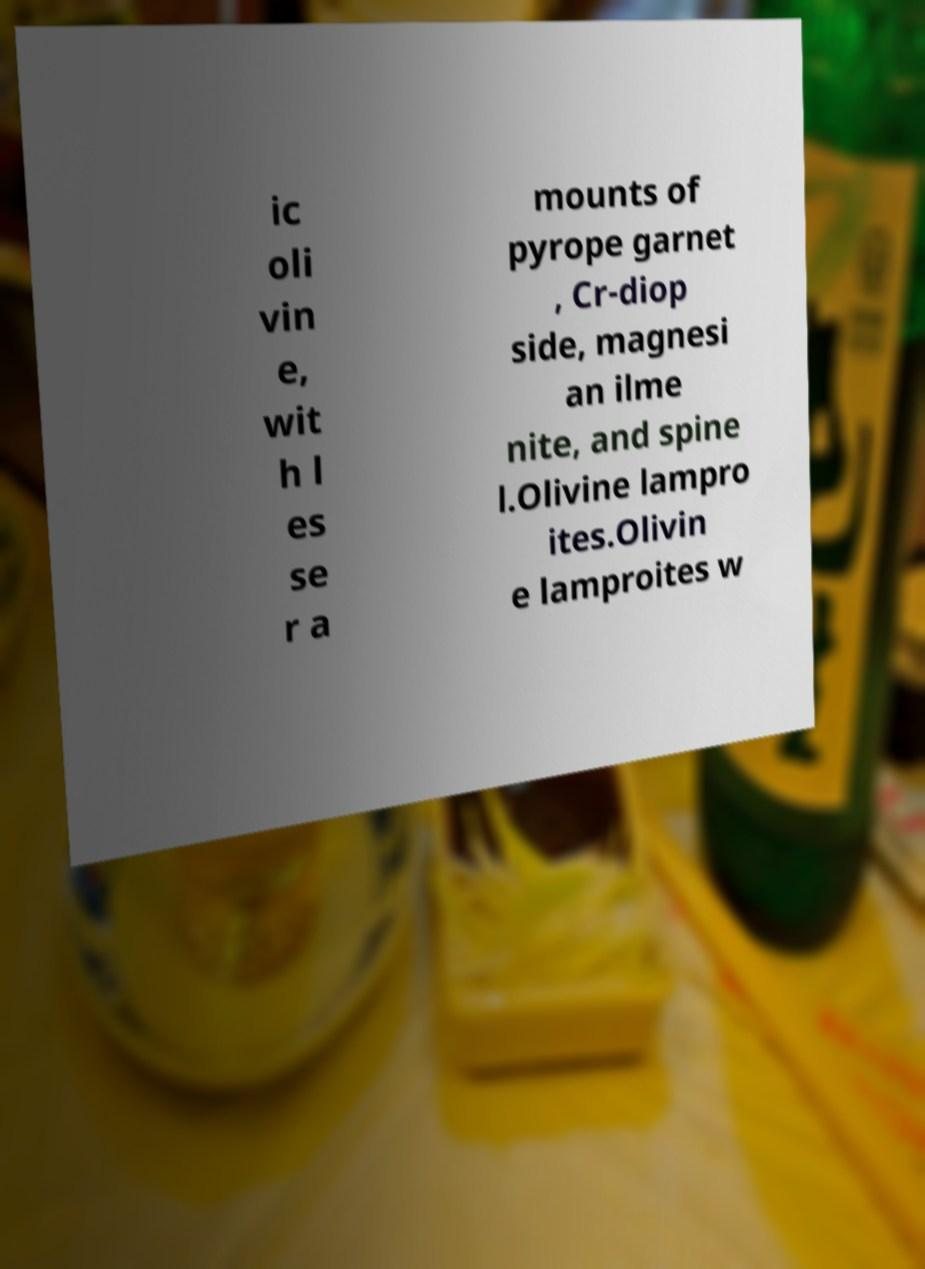Can you accurately transcribe the text from the provided image for me? ic oli vin e, wit h l es se r a mounts of pyrope garnet , Cr-diop side, magnesi an ilme nite, and spine l.Olivine lampro ites.Olivin e lamproites w 